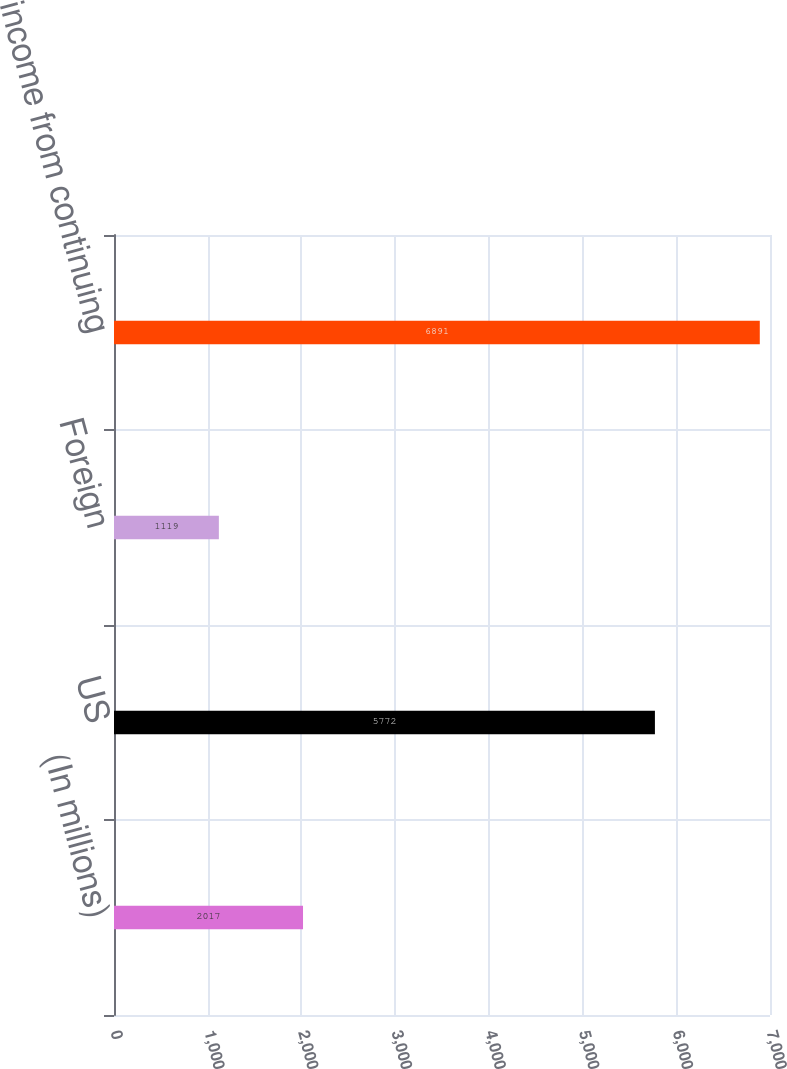<chart> <loc_0><loc_0><loc_500><loc_500><bar_chart><fcel>(In millions)<fcel>US<fcel>Foreign<fcel>Total income from continuing<nl><fcel>2017<fcel>5772<fcel>1119<fcel>6891<nl></chart> 